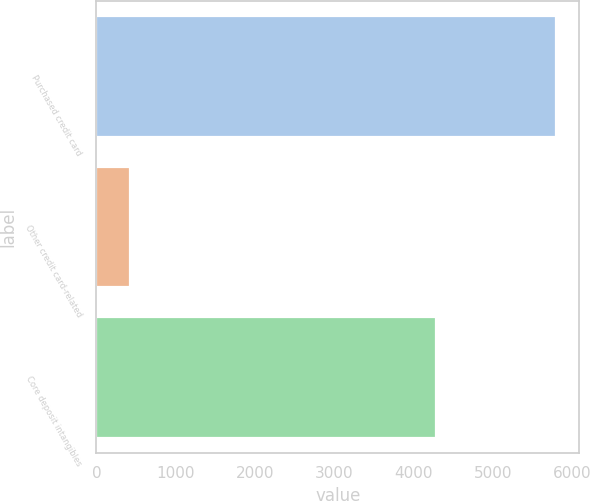Convert chart to OTSL. <chart><loc_0><loc_0><loc_500><loc_500><bar_chart><fcel>Purchased credit card<fcel>Other credit card-related<fcel>Core deposit intangibles<nl><fcel>5794<fcel>422<fcel>4281<nl></chart> 